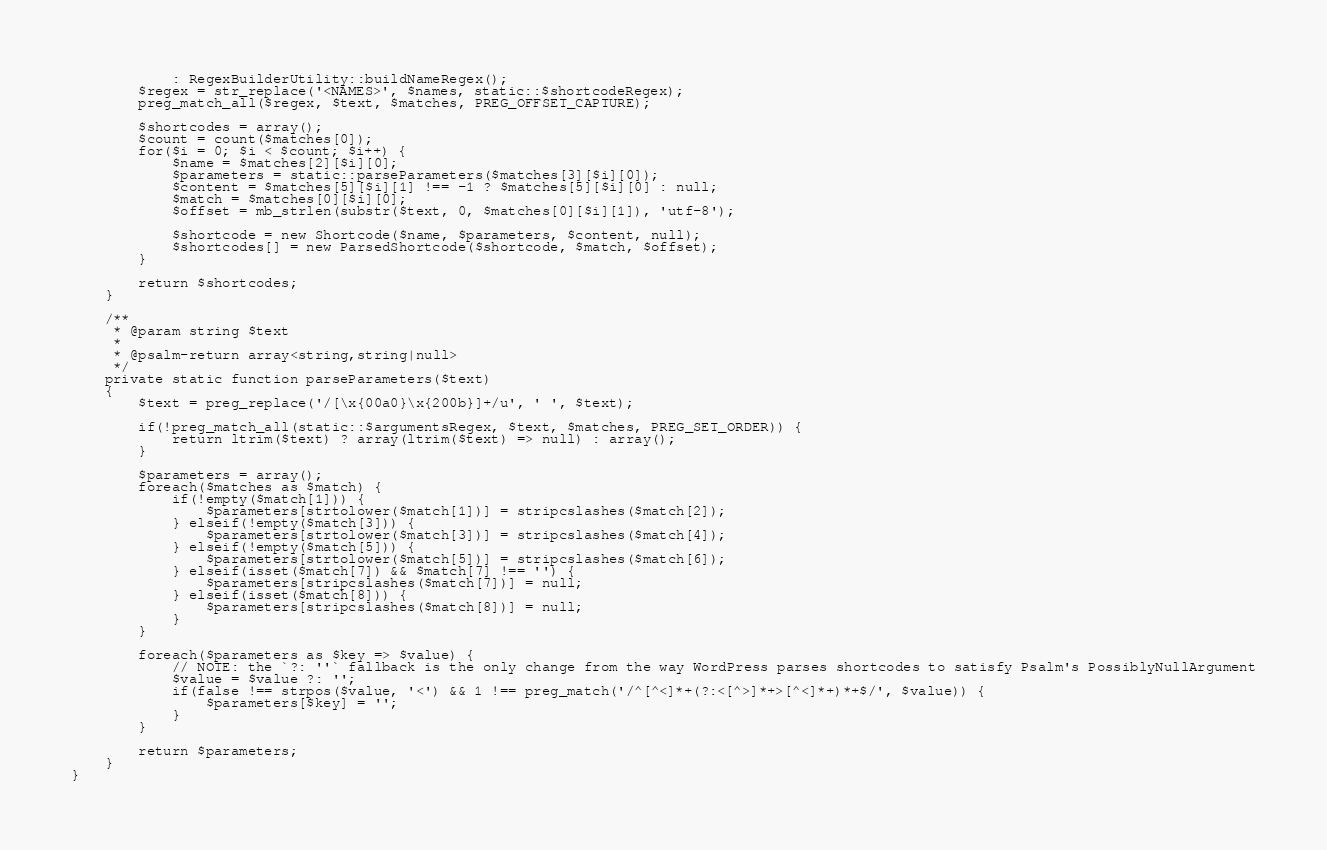Convert code to text. <code><loc_0><loc_0><loc_500><loc_500><_PHP_>            : RegexBuilderUtility::buildNameRegex();
        $regex = str_replace('<NAMES>', $names, static::$shortcodeRegex);
        preg_match_all($regex, $text, $matches, PREG_OFFSET_CAPTURE);

        $shortcodes = array();
        $count = count($matches[0]);
        for($i = 0; $i < $count; $i++) {
            $name = $matches[2][$i][0];
            $parameters = static::parseParameters($matches[3][$i][0]);
            $content = $matches[5][$i][1] !== -1 ? $matches[5][$i][0] : null;
            $match = $matches[0][$i][0];
            $offset = mb_strlen(substr($text, 0, $matches[0][$i][1]), 'utf-8');

            $shortcode = new Shortcode($name, $parameters, $content, null);
            $shortcodes[] = new ParsedShortcode($shortcode, $match, $offset);
        }

        return $shortcodes;
    }

    /**
     * @param string $text
     *
     * @psalm-return array<string,string|null>
     */
    private static function parseParameters($text)
    {
        $text = preg_replace('/[\x{00a0}\x{200b}]+/u', ' ', $text);

        if(!preg_match_all(static::$argumentsRegex, $text, $matches, PREG_SET_ORDER)) {
            return ltrim($text) ? array(ltrim($text) => null) : array();
        }

        $parameters = array();
        foreach($matches as $match) {
            if(!empty($match[1])) {
                $parameters[strtolower($match[1])] = stripcslashes($match[2]);
            } elseif(!empty($match[3])) {
                $parameters[strtolower($match[3])] = stripcslashes($match[4]);
            } elseif(!empty($match[5])) {
                $parameters[strtolower($match[5])] = stripcslashes($match[6]);
            } elseif(isset($match[7]) && $match[7] !== '') {
                $parameters[stripcslashes($match[7])] = null;
            } elseif(isset($match[8])) {
                $parameters[stripcslashes($match[8])] = null;
            }
        }

        foreach($parameters as $key => $value) {
            // NOTE: the `?: ''` fallback is the only change from the way WordPress parses shortcodes to satisfy Psalm's PossiblyNullArgument
            $value = $value ?: '';
            if(false !== strpos($value, '<') && 1 !== preg_match('/^[^<]*+(?:<[^>]*+>[^<]*+)*+$/', $value)) {
                $parameters[$key] = '';
            }
        }

        return $parameters;
    }
}
</code> 